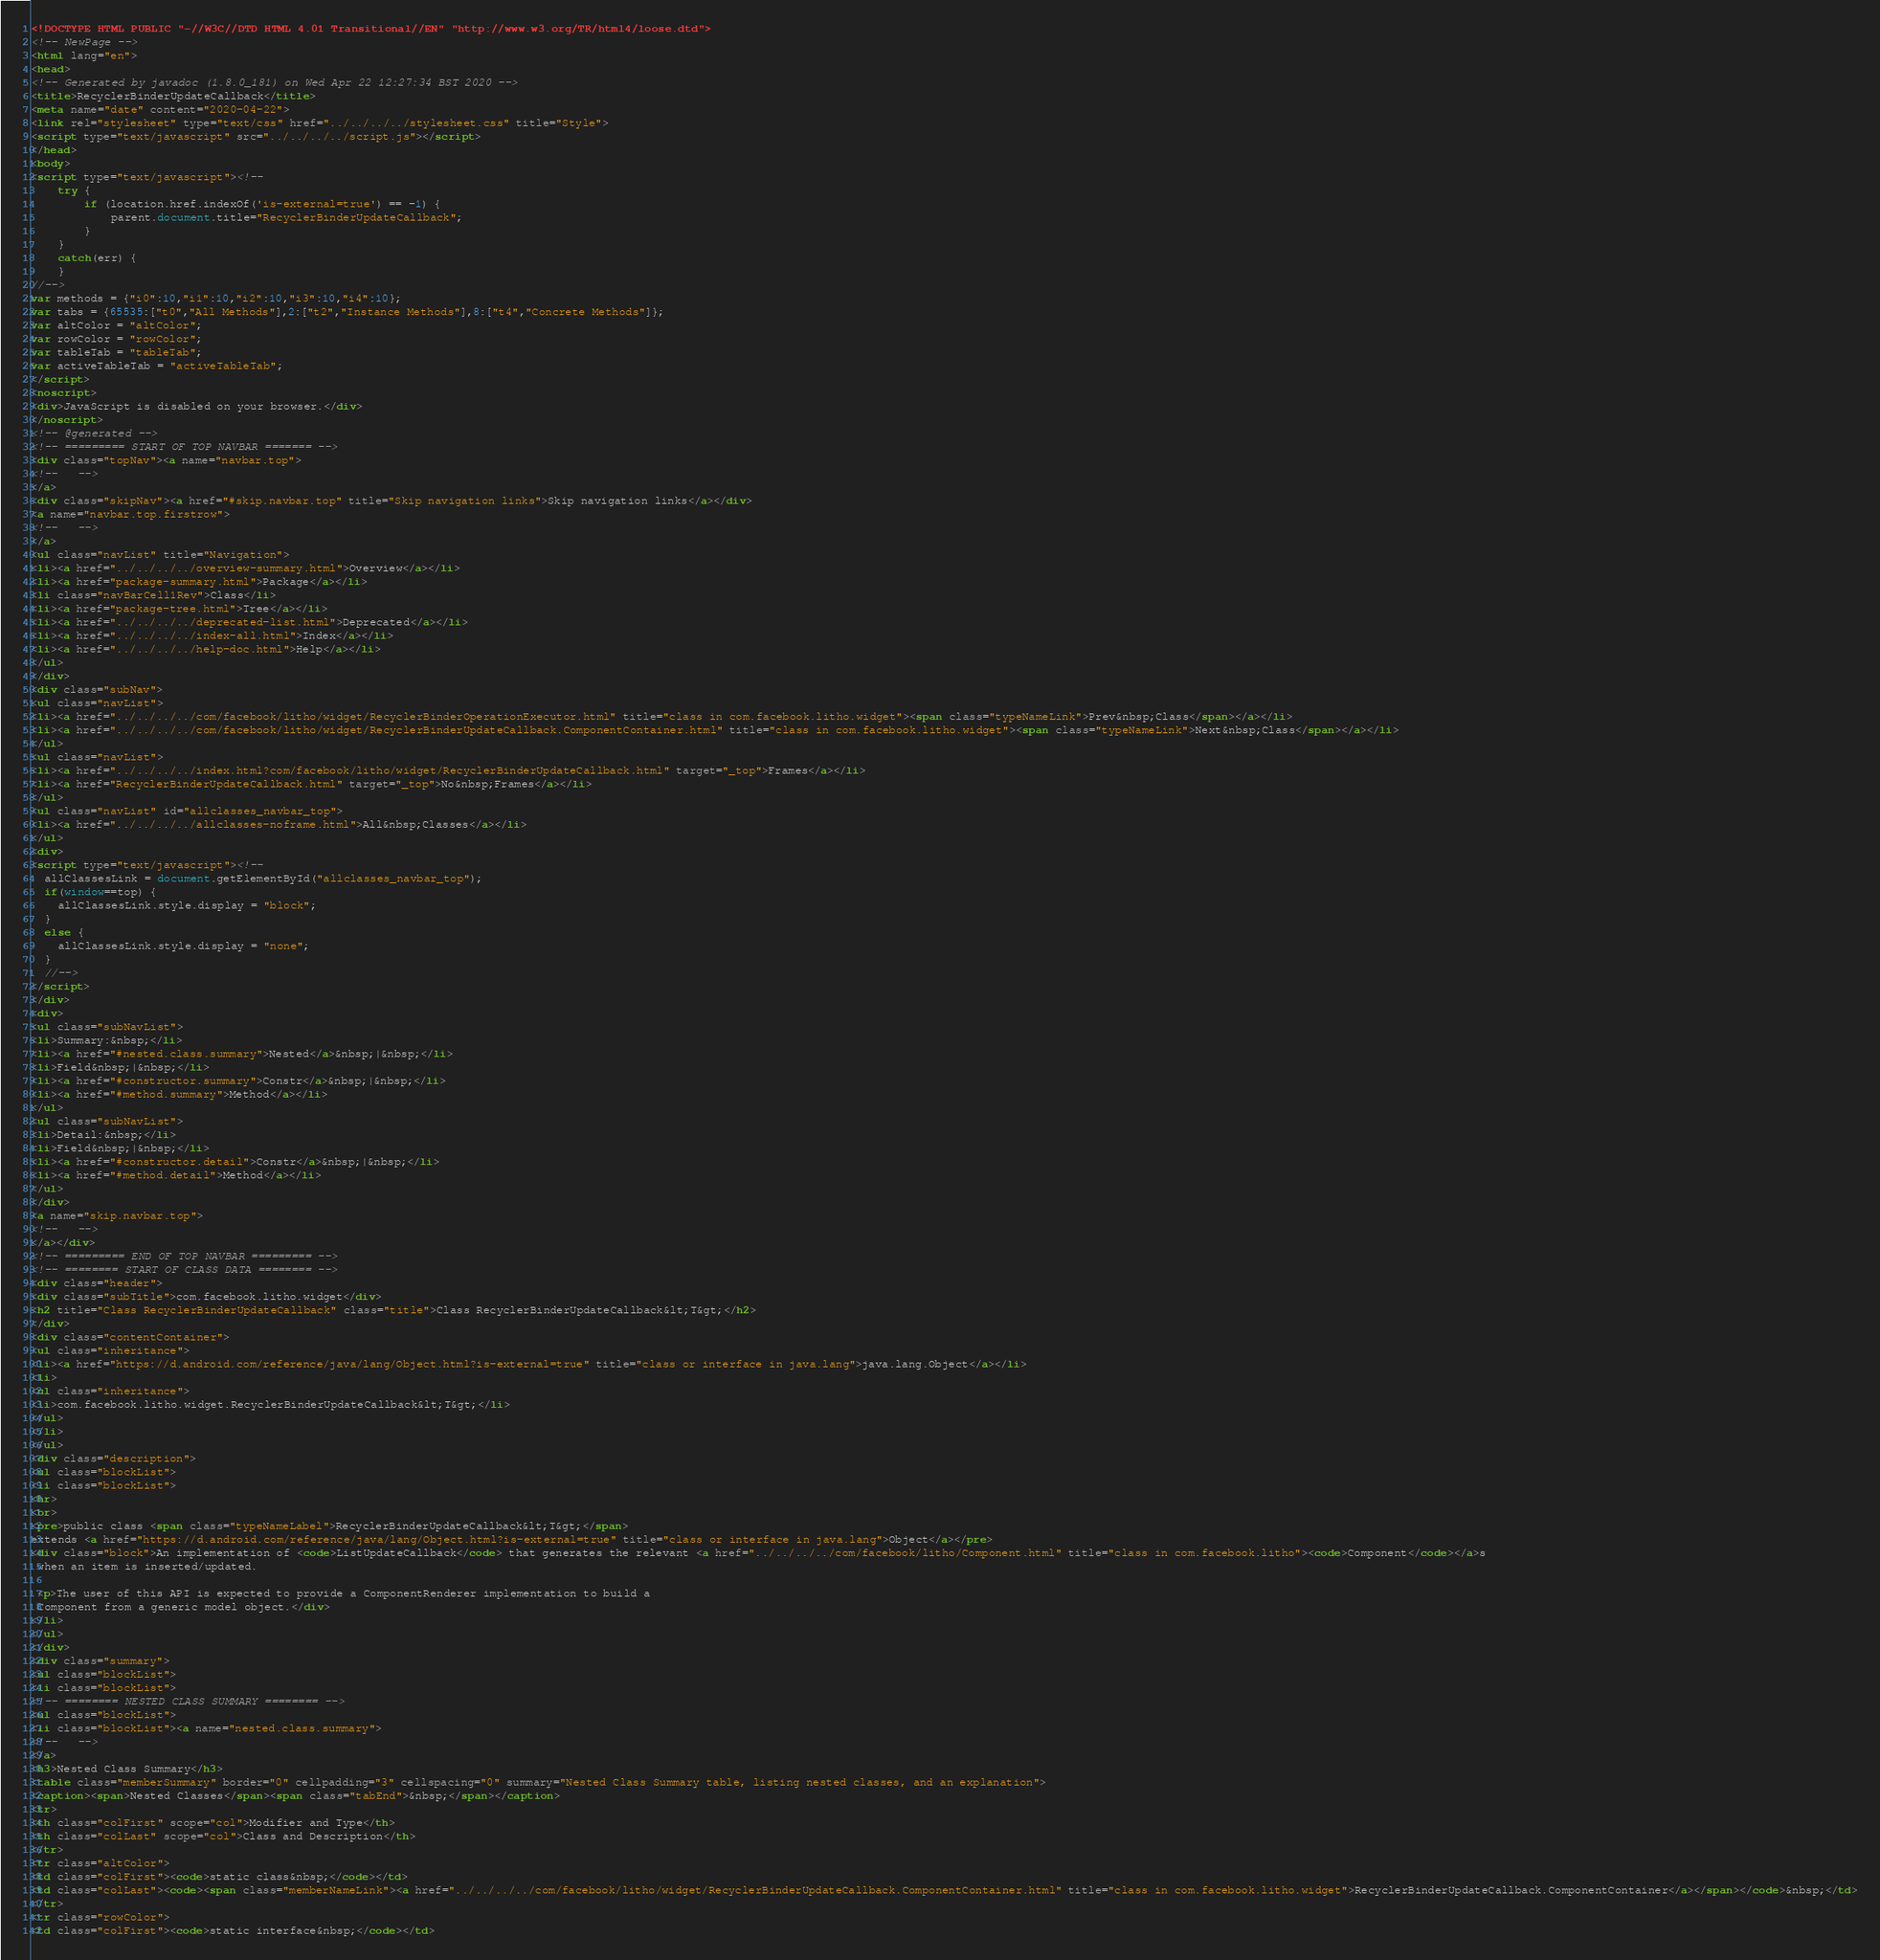Convert code to text. <code><loc_0><loc_0><loc_500><loc_500><_HTML_><!DOCTYPE HTML PUBLIC "-//W3C//DTD HTML 4.01 Transitional//EN" "http://www.w3.org/TR/html4/loose.dtd">
<!-- NewPage -->
<html lang="en">
<head>
<!-- Generated by javadoc (1.8.0_181) on Wed Apr 22 12:27:34 BST 2020 -->
<title>RecyclerBinderUpdateCallback</title>
<meta name="date" content="2020-04-22">
<link rel="stylesheet" type="text/css" href="../../../../stylesheet.css" title="Style">
<script type="text/javascript" src="../../../../script.js"></script>
</head>
<body>
<script type="text/javascript"><!--
    try {
        if (location.href.indexOf('is-external=true') == -1) {
            parent.document.title="RecyclerBinderUpdateCallback";
        }
    }
    catch(err) {
    }
//-->
var methods = {"i0":10,"i1":10,"i2":10,"i3":10,"i4":10};
var tabs = {65535:["t0","All Methods"],2:["t2","Instance Methods"],8:["t4","Concrete Methods"]};
var altColor = "altColor";
var rowColor = "rowColor";
var tableTab = "tableTab";
var activeTableTab = "activeTableTab";
</script>
<noscript>
<div>JavaScript is disabled on your browser.</div>
</noscript>
<!-- @generated -->
<!-- ========= START OF TOP NAVBAR ======= -->
<div class="topNav"><a name="navbar.top">
<!--   -->
</a>
<div class="skipNav"><a href="#skip.navbar.top" title="Skip navigation links">Skip navigation links</a></div>
<a name="navbar.top.firstrow">
<!--   -->
</a>
<ul class="navList" title="Navigation">
<li><a href="../../../../overview-summary.html">Overview</a></li>
<li><a href="package-summary.html">Package</a></li>
<li class="navBarCell1Rev">Class</li>
<li><a href="package-tree.html">Tree</a></li>
<li><a href="../../../../deprecated-list.html">Deprecated</a></li>
<li><a href="../../../../index-all.html">Index</a></li>
<li><a href="../../../../help-doc.html">Help</a></li>
</ul>
</div>
<div class="subNav">
<ul class="navList">
<li><a href="../../../../com/facebook/litho/widget/RecyclerBinderOperationExecutor.html" title="class in com.facebook.litho.widget"><span class="typeNameLink">Prev&nbsp;Class</span></a></li>
<li><a href="../../../../com/facebook/litho/widget/RecyclerBinderUpdateCallback.ComponentContainer.html" title="class in com.facebook.litho.widget"><span class="typeNameLink">Next&nbsp;Class</span></a></li>
</ul>
<ul class="navList">
<li><a href="../../../../index.html?com/facebook/litho/widget/RecyclerBinderUpdateCallback.html" target="_top">Frames</a></li>
<li><a href="RecyclerBinderUpdateCallback.html" target="_top">No&nbsp;Frames</a></li>
</ul>
<ul class="navList" id="allclasses_navbar_top">
<li><a href="../../../../allclasses-noframe.html">All&nbsp;Classes</a></li>
</ul>
<div>
<script type="text/javascript"><!--
  allClassesLink = document.getElementById("allclasses_navbar_top");
  if(window==top) {
    allClassesLink.style.display = "block";
  }
  else {
    allClassesLink.style.display = "none";
  }
  //-->
</script>
</div>
<div>
<ul class="subNavList">
<li>Summary:&nbsp;</li>
<li><a href="#nested.class.summary">Nested</a>&nbsp;|&nbsp;</li>
<li>Field&nbsp;|&nbsp;</li>
<li><a href="#constructor.summary">Constr</a>&nbsp;|&nbsp;</li>
<li><a href="#method.summary">Method</a></li>
</ul>
<ul class="subNavList">
<li>Detail:&nbsp;</li>
<li>Field&nbsp;|&nbsp;</li>
<li><a href="#constructor.detail">Constr</a>&nbsp;|&nbsp;</li>
<li><a href="#method.detail">Method</a></li>
</ul>
</div>
<a name="skip.navbar.top">
<!--   -->
</a></div>
<!-- ========= END OF TOP NAVBAR ========= -->
<!-- ======== START OF CLASS DATA ======== -->
<div class="header">
<div class="subTitle">com.facebook.litho.widget</div>
<h2 title="Class RecyclerBinderUpdateCallback" class="title">Class RecyclerBinderUpdateCallback&lt;T&gt;</h2>
</div>
<div class="contentContainer">
<ul class="inheritance">
<li><a href="https://d.android.com/reference/java/lang/Object.html?is-external=true" title="class or interface in java.lang">java.lang.Object</a></li>
<li>
<ul class="inheritance">
<li>com.facebook.litho.widget.RecyclerBinderUpdateCallback&lt;T&gt;</li>
</ul>
</li>
</ul>
<div class="description">
<ul class="blockList">
<li class="blockList">
<hr>
<br>
<pre>public class <span class="typeNameLabel">RecyclerBinderUpdateCallback&lt;T&gt;</span>
extends <a href="https://d.android.com/reference/java/lang/Object.html?is-external=true" title="class or interface in java.lang">Object</a></pre>
<div class="block">An implementation of <code>ListUpdateCallback</code> that generates the relevant <a href="../../../../com/facebook/litho/Component.html" title="class in com.facebook.litho"><code>Component</code></a>s
 when an item is inserted/updated.

 <p>The user of this API is expected to provide a ComponentRenderer implementation to build a
 Component from a generic model object.</div>
</li>
</ul>
</div>
<div class="summary">
<ul class="blockList">
<li class="blockList">
<!-- ======== NESTED CLASS SUMMARY ======== -->
<ul class="blockList">
<li class="blockList"><a name="nested.class.summary">
<!--   -->
</a>
<h3>Nested Class Summary</h3>
<table class="memberSummary" border="0" cellpadding="3" cellspacing="0" summary="Nested Class Summary table, listing nested classes, and an explanation">
<caption><span>Nested Classes</span><span class="tabEnd">&nbsp;</span></caption>
<tr>
<th class="colFirst" scope="col">Modifier and Type</th>
<th class="colLast" scope="col">Class and Description</th>
</tr>
<tr class="altColor">
<td class="colFirst"><code>static class&nbsp;</code></td>
<td class="colLast"><code><span class="memberNameLink"><a href="../../../../com/facebook/litho/widget/RecyclerBinderUpdateCallback.ComponentContainer.html" title="class in com.facebook.litho.widget">RecyclerBinderUpdateCallback.ComponentContainer</a></span></code>&nbsp;</td>
</tr>
<tr class="rowColor">
<td class="colFirst"><code>static interface&nbsp;</code></td></code> 